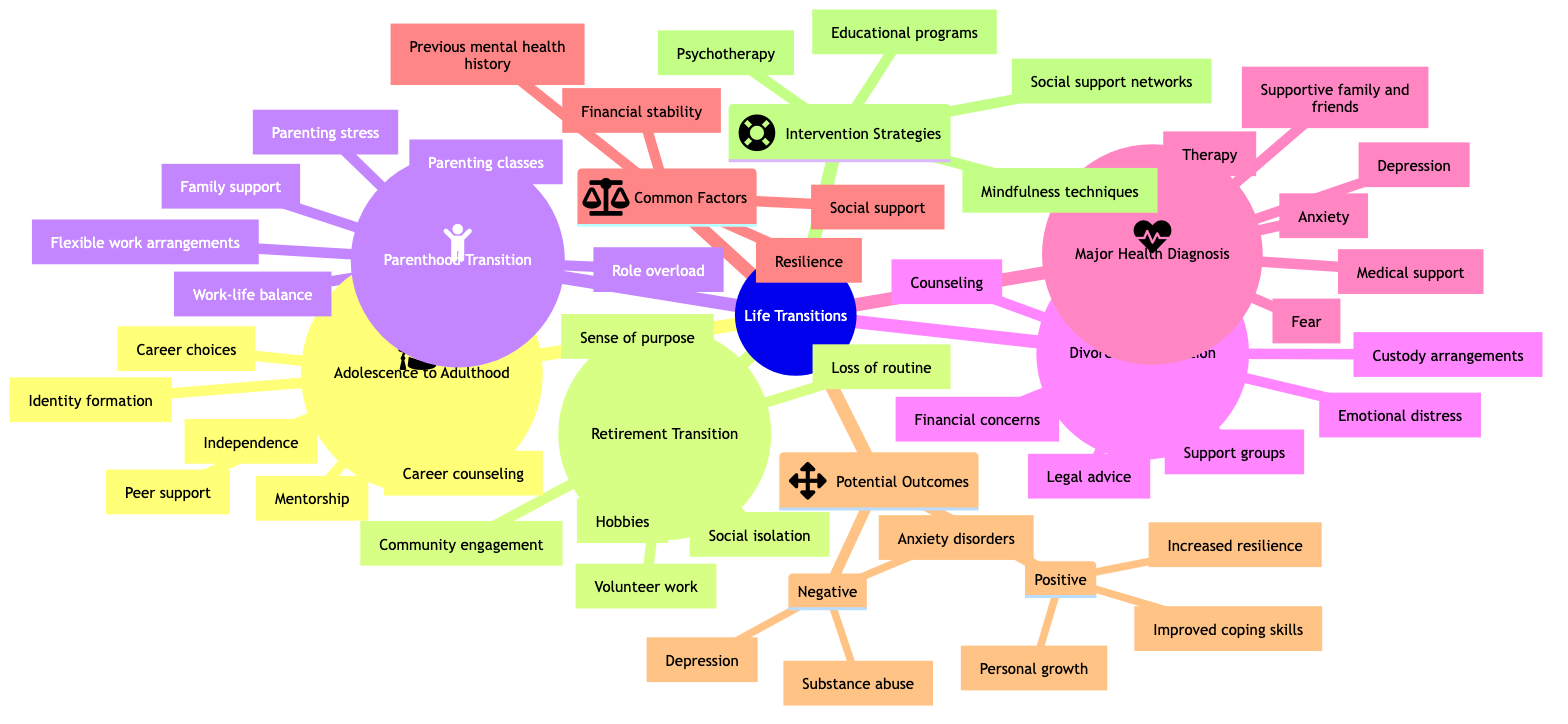What are the common factors influencing the impact of life transitions on mental health? According to the diagram, the common factors listed are resilience, social support, financial stability, and previous mental health history.
Answer: Resilience, social support, financial stability, previous mental health history How many types of life transitions are identified in the diagram? The diagram lists five types of life transitions: Adolescence to Adulthood, Retirement Transition, Parenthood Transition, Divorce or Separation, and Major Health Diagnosis.
Answer: Five What is a psychological challenge associated with retirement transition? The diagram specifically points out three challenges related to retirement transition: loss of routine, social isolation, and sense of purpose. One of those challenges is loss of routine.
Answer: Loss of routine What is a potential positive outcome of life transitions? The diagram highlights three potential positive outcomes: increased resilience, personal growth, and improved coping skills. One of those outcomes is increased resilience.
Answer: Increased resilience Which supporting factor is common throughout various life transitions? By examining the supporting factors listed for various transitions, social support appears as a consistent supporting factor, particularly in the contexts of adolescence to adulthood and major health diagnosis.
Answer: Social support What psychological challenges are associated with divorce or separation? The diagram specifically outlines three psychological challenges related to divorce or separation: emotional distress, custody arrangements, and financial concerns. One of those challenges is emotional distress.
Answer: Emotional distress What intervention strategy addresses anxiety stemming from major health diagnosis? The diagram shows that therapy is among the intervention strategies specifically listed to help address the psychological challenges stemming from major health diagnosis.
Answer: Therapy What is a common negative outcome of life transitions? The diagram lists three negative outcomes related to life transitions: anxiety disorders, depression, and substance abuse. One of these outcomes is anxiety disorders.
Answer: Anxiety disorders Which transition involves challenges related to role overload? The transition to parenthood involves specific challenges, one of which is role overload, as noted in the psychological challenges section of the diagram.
Answer: Parenthood Transition What are the supporting factors associated with major health diagnosis? The diagram mentions three supporting factors for major health diagnosis: medical support, therapy, and supportive family and friends. One of those factors is medical support.
Answer: Medical support 